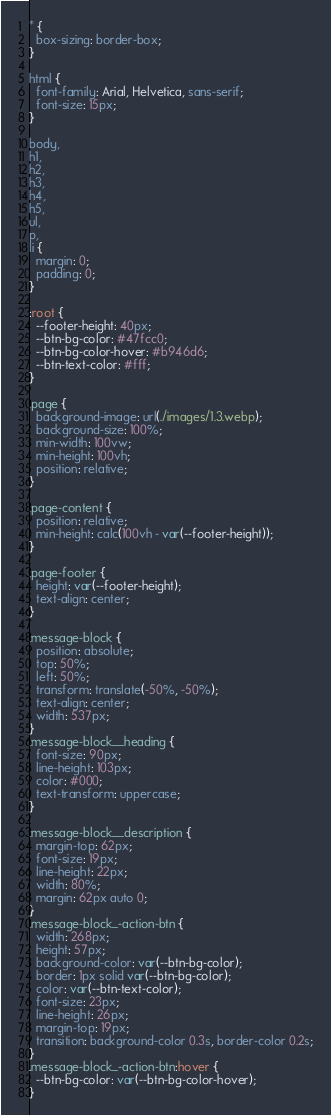<code> <loc_0><loc_0><loc_500><loc_500><_CSS_>* {
  box-sizing: border-box;
}

html {
  font-family: Arial, Helvetica, sans-serif;
  font-size: 15px;
}

body,
h1,
h2,
h3,
h4,
h5,
ul,
p,
li {
  margin: 0;
  padding: 0;
}

:root {
  --footer-height: 40px;
  --btn-bg-color: #47fcc0;
  --btn-bg-color-hover: #b946d6;
  --btn-text-color: #fff;
}

.page {
  background-image: url(./images/1.3.webp);
  background-size: 100%;
  min-width: 100vw;
  min-height: 100vh;
  position: relative;
}

.page-content {
  position: relative;
  min-height: calc(100vh - var(--footer-height));
}

.page-footer {
  height: var(--footer-height);
  text-align: center;
}

.message-block {
  position: absolute;
  top: 50%;
  left: 50%;
  transform: translate(-50%, -50%);
  text-align: center;
  width: 537px;
}
.message-block__heading {
  font-size: 90px;
  line-height: 103px;
  color: #000;
  text-transform: uppercase;
}

.message-block__description {
  margin-top: 62px;
  font-size: 19px;
  line-height: 22px;
  width: 80%;
  margin: 62px auto 0;
}
.message-block_-action-btn {
  width: 268px;
  height: 57px;
  background-color: var(--btn-bg-color);
  border: 1px solid var(--btn-bg-color);
  color: var(--btn-text-color);
  font-size: 23px;
  line-height: 26px;
  margin-top: 19px;
  transition: background-color 0.3s, border-color 0.2s;
}
.message-block_-action-btn:hover {
  --btn-bg-color: var(--btn-bg-color-hover);
}
</code> 